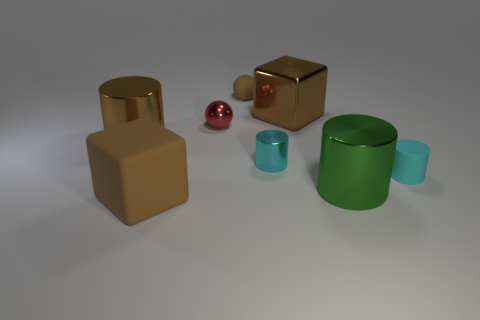Subtract all brown shiny cylinders. How many cylinders are left? 3 Subtract all yellow cubes. How many cyan cylinders are left? 2 Add 1 small cyan metal cylinders. How many objects exist? 9 Subtract all green cylinders. How many cylinders are left? 3 Subtract all balls. How many objects are left? 6 Subtract all purple cylinders. Subtract all gray blocks. How many cylinders are left? 4 Subtract all brown cubes. Subtract all brown cubes. How many objects are left? 4 Add 3 small shiny cylinders. How many small shiny cylinders are left? 4 Add 8 big brown shiny cubes. How many big brown shiny cubes exist? 9 Subtract 1 green cylinders. How many objects are left? 7 